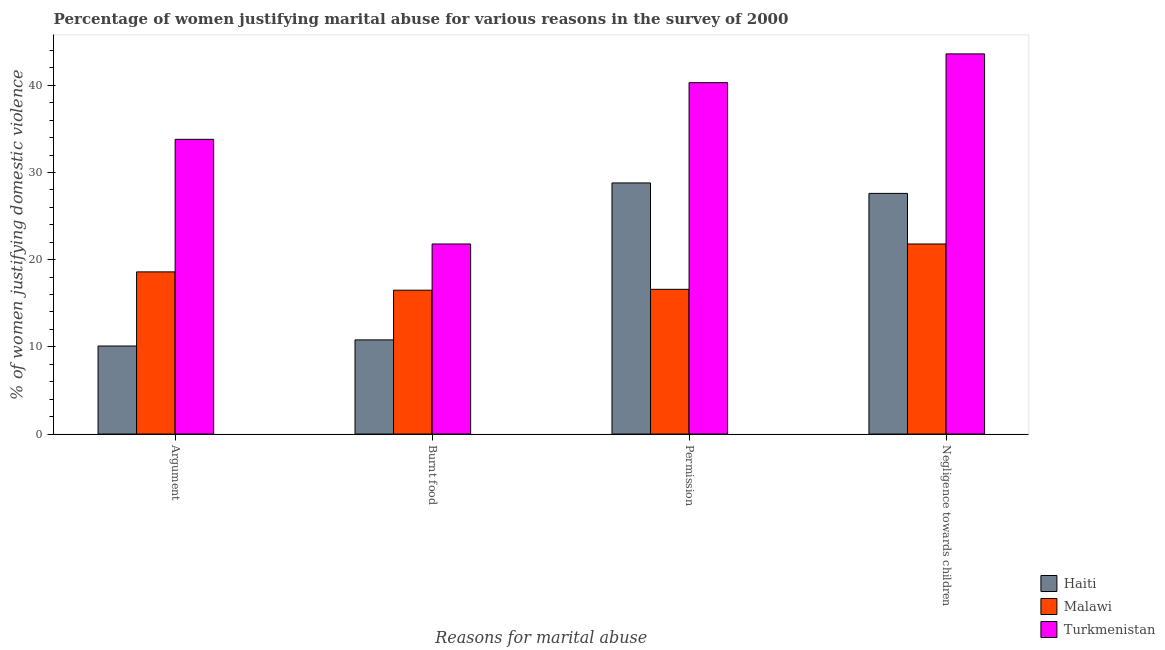How many groups of bars are there?
Give a very brief answer. 4. Are the number of bars per tick equal to the number of legend labels?
Ensure brevity in your answer.  Yes. Are the number of bars on each tick of the X-axis equal?
Your response must be concise. Yes. How many bars are there on the 1st tick from the right?
Offer a terse response. 3. What is the label of the 1st group of bars from the left?
Offer a very short reply. Argument. What is the percentage of women justifying abuse for going without permission in Haiti?
Your response must be concise. 28.8. Across all countries, what is the maximum percentage of women justifying abuse for showing negligence towards children?
Give a very brief answer. 43.6. In which country was the percentage of women justifying abuse for burning food maximum?
Your response must be concise. Turkmenistan. In which country was the percentage of women justifying abuse in the case of an argument minimum?
Make the answer very short. Haiti. What is the total percentage of women justifying abuse for burning food in the graph?
Provide a succinct answer. 49.1. What is the difference between the percentage of women justifying abuse for burning food in Malawi and that in Turkmenistan?
Ensure brevity in your answer.  -5.3. What is the average percentage of women justifying abuse for burning food per country?
Your answer should be compact. 16.37. What is the difference between the percentage of women justifying abuse in the case of an argument and percentage of women justifying abuse for burning food in Haiti?
Ensure brevity in your answer.  -0.7. In how many countries, is the percentage of women justifying abuse for burning food greater than 10 %?
Offer a terse response. 3. What is the ratio of the percentage of women justifying abuse for going without permission in Malawi to that in Turkmenistan?
Provide a succinct answer. 0.41. Is the difference between the percentage of women justifying abuse for showing negligence towards children in Turkmenistan and Haiti greater than the difference between the percentage of women justifying abuse for going without permission in Turkmenistan and Haiti?
Your response must be concise. Yes. What is the difference between the highest and the lowest percentage of women justifying abuse for showing negligence towards children?
Your response must be concise. 21.8. In how many countries, is the percentage of women justifying abuse in the case of an argument greater than the average percentage of women justifying abuse in the case of an argument taken over all countries?
Give a very brief answer. 1. Is the sum of the percentage of women justifying abuse in the case of an argument in Malawi and Haiti greater than the maximum percentage of women justifying abuse for showing negligence towards children across all countries?
Keep it short and to the point. No. Is it the case that in every country, the sum of the percentage of women justifying abuse for going without permission and percentage of women justifying abuse for showing negligence towards children is greater than the sum of percentage of women justifying abuse for burning food and percentage of women justifying abuse in the case of an argument?
Give a very brief answer. No. What does the 2nd bar from the left in Argument represents?
Your response must be concise. Malawi. What does the 2nd bar from the right in Permission represents?
Provide a short and direct response. Malawi. Is it the case that in every country, the sum of the percentage of women justifying abuse in the case of an argument and percentage of women justifying abuse for burning food is greater than the percentage of women justifying abuse for going without permission?
Give a very brief answer. No. How many bars are there?
Offer a terse response. 12. Are all the bars in the graph horizontal?
Your answer should be very brief. No. How many countries are there in the graph?
Give a very brief answer. 3. What is the difference between two consecutive major ticks on the Y-axis?
Provide a short and direct response. 10. Are the values on the major ticks of Y-axis written in scientific E-notation?
Ensure brevity in your answer.  No. Does the graph contain any zero values?
Ensure brevity in your answer.  No. Where does the legend appear in the graph?
Your response must be concise. Bottom right. How many legend labels are there?
Ensure brevity in your answer.  3. How are the legend labels stacked?
Your response must be concise. Vertical. What is the title of the graph?
Provide a succinct answer. Percentage of women justifying marital abuse for various reasons in the survey of 2000. Does "Togo" appear as one of the legend labels in the graph?
Make the answer very short. No. What is the label or title of the X-axis?
Offer a terse response. Reasons for marital abuse. What is the label or title of the Y-axis?
Your answer should be very brief. % of women justifying domestic violence. What is the % of women justifying domestic violence in Malawi in Argument?
Your response must be concise. 18.6. What is the % of women justifying domestic violence in Turkmenistan in Argument?
Offer a very short reply. 33.8. What is the % of women justifying domestic violence in Malawi in Burnt food?
Give a very brief answer. 16.5. What is the % of women justifying domestic violence in Turkmenistan in Burnt food?
Offer a very short reply. 21.8. What is the % of women justifying domestic violence of Haiti in Permission?
Offer a terse response. 28.8. What is the % of women justifying domestic violence of Malawi in Permission?
Your response must be concise. 16.6. What is the % of women justifying domestic violence in Turkmenistan in Permission?
Provide a succinct answer. 40.3. What is the % of women justifying domestic violence in Haiti in Negligence towards children?
Offer a terse response. 27.6. What is the % of women justifying domestic violence in Malawi in Negligence towards children?
Your answer should be compact. 21.8. What is the % of women justifying domestic violence of Turkmenistan in Negligence towards children?
Offer a very short reply. 43.6. Across all Reasons for marital abuse, what is the maximum % of women justifying domestic violence of Haiti?
Give a very brief answer. 28.8. Across all Reasons for marital abuse, what is the maximum % of women justifying domestic violence in Malawi?
Ensure brevity in your answer.  21.8. Across all Reasons for marital abuse, what is the maximum % of women justifying domestic violence in Turkmenistan?
Provide a short and direct response. 43.6. Across all Reasons for marital abuse, what is the minimum % of women justifying domestic violence in Turkmenistan?
Ensure brevity in your answer.  21.8. What is the total % of women justifying domestic violence in Haiti in the graph?
Offer a very short reply. 77.3. What is the total % of women justifying domestic violence of Malawi in the graph?
Ensure brevity in your answer.  73.5. What is the total % of women justifying domestic violence in Turkmenistan in the graph?
Provide a succinct answer. 139.5. What is the difference between the % of women justifying domestic violence in Haiti in Argument and that in Burnt food?
Your response must be concise. -0.7. What is the difference between the % of women justifying domestic violence of Turkmenistan in Argument and that in Burnt food?
Give a very brief answer. 12. What is the difference between the % of women justifying domestic violence of Haiti in Argument and that in Permission?
Your answer should be very brief. -18.7. What is the difference between the % of women justifying domestic violence in Haiti in Argument and that in Negligence towards children?
Offer a terse response. -17.5. What is the difference between the % of women justifying domestic violence of Turkmenistan in Burnt food and that in Permission?
Give a very brief answer. -18.5. What is the difference between the % of women justifying domestic violence in Haiti in Burnt food and that in Negligence towards children?
Offer a terse response. -16.8. What is the difference between the % of women justifying domestic violence of Malawi in Burnt food and that in Negligence towards children?
Provide a short and direct response. -5.3. What is the difference between the % of women justifying domestic violence in Turkmenistan in Burnt food and that in Negligence towards children?
Keep it short and to the point. -21.8. What is the difference between the % of women justifying domestic violence in Haiti in Permission and that in Negligence towards children?
Provide a short and direct response. 1.2. What is the difference between the % of women justifying domestic violence in Turkmenistan in Permission and that in Negligence towards children?
Keep it short and to the point. -3.3. What is the difference between the % of women justifying domestic violence of Haiti in Argument and the % of women justifying domestic violence of Turkmenistan in Burnt food?
Keep it short and to the point. -11.7. What is the difference between the % of women justifying domestic violence of Haiti in Argument and the % of women justifying domestic violence of Turkmenistan in Permission?
Make the answer very short. -30.2. What is the difference between the % of women justifying domestic violence of Malawi in Argument and the % of women justifying domestic violence of Turkmenistan in Permission?
Provide a short and direct response. -21.7. What is the difference between the % of women justifying domestic violence of Haiti in Argument and the % of women justifying domestic violence of Malawi in Negligence towards children?
Ensure brevity in your answer.  -11.7. What is the difference between the % of women justifying domestic violence in Haiti in Argument and the % of women justifying domestic violence in Turkmenistan in Negligence towards children?
Offer a very short reply. -33.5. What is the difference between the % of women justifying domestic violence of Haiti in Burnt food and the % of women justifying domestic violence of Malawi in Permission?
Ensure brevity in your answer.  -5.8. What is the difference between the % of women justifying domestic violence in Haiti in Burnt food and the % of women justifying domestic violence in Turkmenistan in Permission?
Keep it short and to the point. -29.5. What is the difference between the % of women justifying domestic violence in Malawi in Burnt food and the % of women justifying domestic violence in Turkmenistan in Permission?
Make the answer very short. -23.8. What is the difference between the % of women justifying domestic violence of Haiti in Burnt food and the % of women justifying domestic violence of Malawi in Negligence towards children?
Provide a short and direct response. -11. What is the difference between the % of women justifying domestic violence in Haiti in Burnt food and the % of women justifying domestic violence in Turkmenistan in Negligence towards children?
Your answer should be very brief. -32.8. What is the difference between the % of women justifying domestic violence in Malawi in Burnt food and the % of women justifying domestic violence in Turkmenistan in Negligence towards children?
Offer a very short reply. -27.1. What is the difference between the % of women justifying domestic violence in Haiti in Permission and the % of women justifying domestic violence in Malawi in Negligence towards children?
Keep it short and to the point. 7. What is the difference between the % of women justifying domestic violence in Haiti in Permission and the % of women justifying domestic violence in Turkmenistan in Negligence towards children?
Provide a short and direct response. -14.8. What is the average % of women justifying domestic violence of Haiti per Reasons for marital abuse?
Offer a terse response. 19.32. What is the average % of women justifying domestic violence in Malawi per Reasons for marital abuse?
Give a very brief answer. 18.38. What is the average % of women justifying domestic violence in Turkmenistan per Reasons for marital abuse?
Your answer should be compact. 34.88. What is the difference between the % of women justifying domestic violence of Haiti and % of women justifying domestic violence of Turkmenistan in Argument?
Offer a terse response. -23.7. What is the difference between the % of women justifying domestic violence of Malawi and % of women justifying domestic violence of Turkmenistan in Argument?
Keep it short and to the point. -15.2. What is the difference between the % of women justifying domestic violence of Haiti and % of women justifying domestic violence of Malawi in Burnt food?
Ensure brevity in your answer.  -5.7. What is the difference between the % of women justifying domestic violence of Haiti and % of women justifying domestic violence of Turkmenistan in Burnt food?
Your answer should be compact. -11. What is the difference between the % of women justifying domestic violence of Malawi and % of women justifying domestic violence of Turkmenistan in Burnt food?
Keep it short and to the point. -5.3. What is the difference between the % of women justifying domestic violence of Malawi and % of women justifying domestic violence of Turkmenistan in Permission?
Provide a succinct answer. -23.7. What is the difference between the % of women justifying domestic violence of Malawi and % of women justifying domestic violence of Turkmenistan in Negligence towards children?
Your response must be concise. -21.8. What is the ratio of the % of women justifying domestic violence of Haiti in Argument to that in Burnt food?
Offer a terse response. 0.94. What is the ratio of the % of women justifying domestic violence in Malawi in Argument to that in Burnt food?
Offer a very short reply. 1.13. What is the ratio of the % of women justifying domestic violence in Turkmenistan in Argument to that in Burnt food?
Your response must be concise. 1.55. What is the ratio of the % of women justifying domestic violence of Haiti in Argument to that in Permission?
Your answer should be very brief. 0.35. What is the ratio of the % of women justifying domestic violence in Malawi in Argument to that in Permission?
Keep it short and to the point. 1.12. What is the ratio of the % of women justifying domestic violence of Turkmenistan in Argument to that in Permission?
Offer a terse response. 0.84. What is the ratio of the % of women justifying domestic violence of Haiti in Argument to that in Negligence towards children?
Make the answer very short. 0.37. What is the ratio of the % of women justifying domestic violence of Malawi in Argument to that in Negligence towards children?
Ensure brevity in your answer.  0.85. What is the ratio of the % of women justifying domestic violence in Turkmenistan in Argument to that in Negligence towards children?
Offer a terse response. 0.78. What is the ratio of the % of women justifying domestic violence in Haiti in Burnt food to that in Permission?
Make the answer very short. 0.38. What is the ratio of the % of women justifying domestic violence of Malawi in Burnt food to that in Permission?
Offer a very short reply. 0.99. What is the ratio of the % of women justifying domestic violence of Turkmenistan in Burnt food to that in Permission?
Make the answer very short. 0.54. What is the ratio of the % of women justifying domestic violence of Haiti in Burnt food to that in Negligence towards children?
Give a very brief answer. 0.39. What is the ratio of the % of women justifying domestic violence in Malawi in Burnt food to that in Negligence towards children?
Provide a short and direct response. 0.76. What is the ratio of the % of women justifying domestic violence in Haiti in Permission to that in Negligence towards children?
Provide a succinct answer. 1.04. What is the ratio of the % of women justifying domestic violence in Malawi in Permission to that in Negligence towards children?
Ensure brevity in your answer.  0.76. What is the ratio of the % of women justifying domestic violence in Turkmenistan in Permission to that in Negligence towards children?
Offer a terse response. 0.92. What is the difference between the highest and the second highest % of women justifying domestic violence in Haiti?
Offer a very short reply. 1.2. What is the difference between the highest and the second highest % of women justifying domestic violence in Malawi?
Your response must be concise. 3.2. What is the difference between the highest and the second highest % of women justifying domestic violence of Turkmenistan?
Give a very brief answer. 3.3. What is the difference between the highest and the lowest % of women justifying domestic violence in Turkmenistan?
Provide a short and direct response. 21.8. 